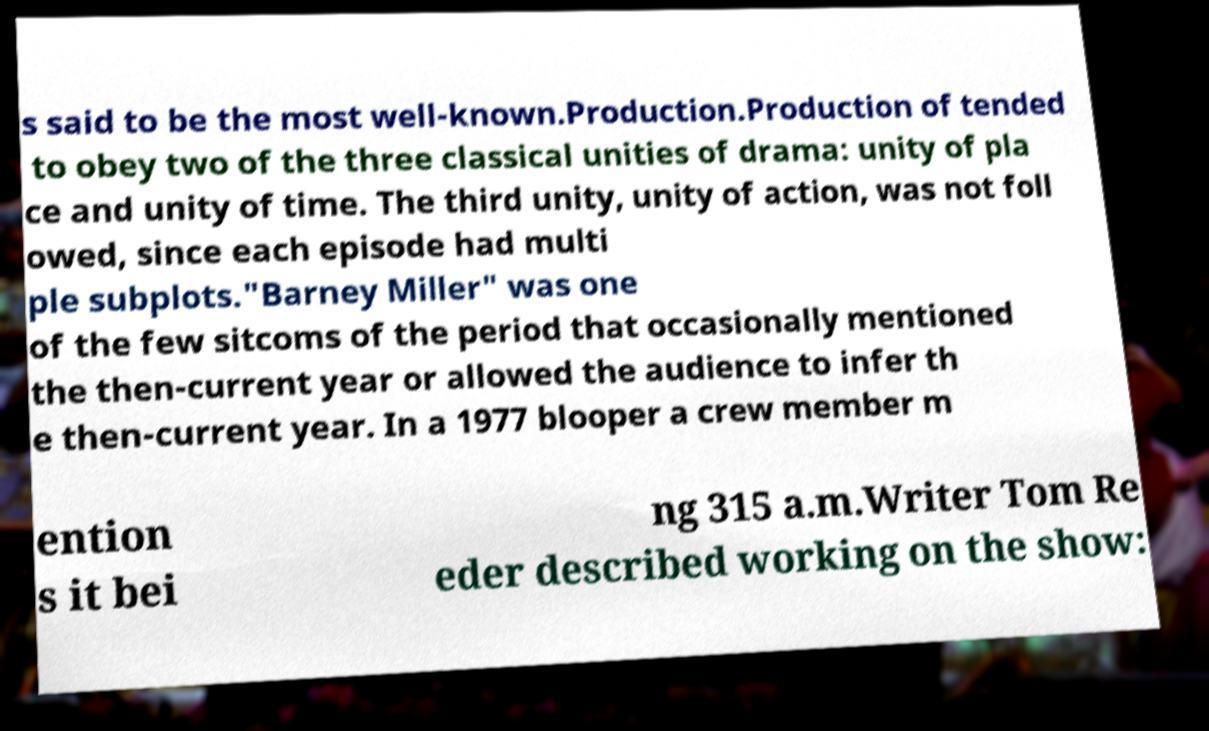There's text embedded in this image that I need extracted. Can you transcribe it verbatim? s said to be the most well-known.Production.Production of tended to obey two of the three classical unities of drama: unity of pla ce and unity of time. The third unity, unity of action, was not foll owed, since each episode had multi ple subplots."Barney Miller" was one of the few sitcoms of the period that occasionally mentioned the then-current year or allowed the audience to infer th e then-current year. In a 1977 blooper a crew member m ention s it bei ng 315 a.m.Writer Tom Re eder described working on the show: 